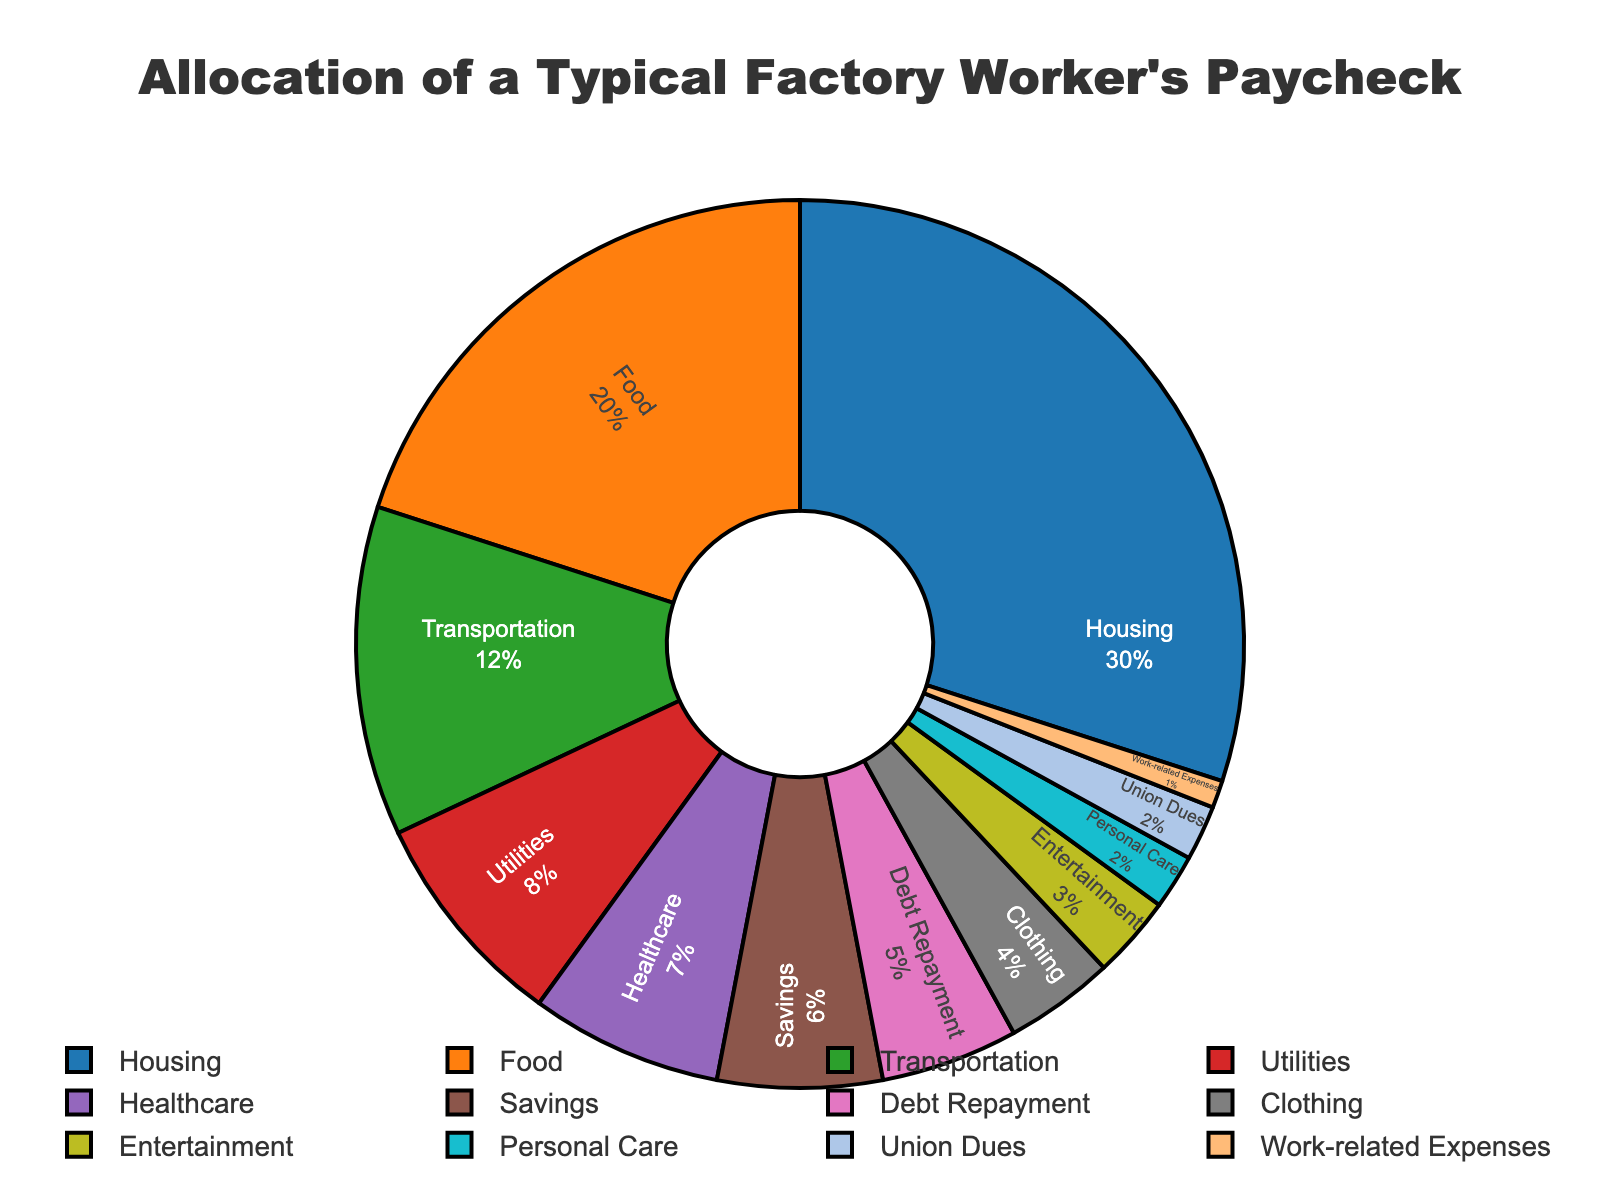which category has the largest allocation of the paycheck? The figure shows that the largest segment is Housing, which is allocated 30% of the paycheck.
Answer: Housing how much more is allocated to housing compared to savings? The figure shows Housing at 30% and Savings at 6%. The difference is calculated as 30% - 6% = 24%.
Answer: 24% what is the total allocation percentage for utilities, healthcare, and transportation combined? Utilities are allocated 8%, healthcare 7%, and transportation 12%. Adding these together, we get 8% + 7% + 12% = 27%.
Answer: 27% what percentage of the paycheck is spent on categories excluding housing and food? Housing is 30% and Food is 20%. The total percentage for all categories is 100%. Subtracting Housing and Food, we get 100% - 30% - 20% = 50%.
Answer: 50% which categories have the smallest allocation? The smallest allocation categories are Union Dues and Work-related Expenses, each at 2% and 1% respectively.
Answer: Union Dues, Work-related Expenses are there more funds allocated to entertainment or clothing? The figure shows Clothing at 4% and Entertainment at 3%. Therefore, Clothing has more funds allocated than Entertainment.
Answer: Clothing how much more is the total allocation for housing, food, and clothing compared to personal care and entertainment combined? The allocations for housing, food, and clothing are 30%, 20%, and 4%, respectively. Their total is 30% + 20% + 4% = 54%. The allocations for personal care and entertainment are 2% and 3%, respectively. Their total is 2% + 3% = 5%. The difference is 54% - 5% = 49%.
Answer: 49% how much of the paycheck is allocated to non-essentials like entertainment, clothing, and personal care? The allocations for entertainment, clothing, and personal care are 3%, 4%, and 2%, respectively. Adding these together, we get 3% + 4% + 2% = 9%.
Answer: 9% which category receives a slightly higher allocation than debt repayment? The figure shows that Savings is allocated 6%, which is slightly higher than Debt Repayment at 5%.
Answer: Savings 